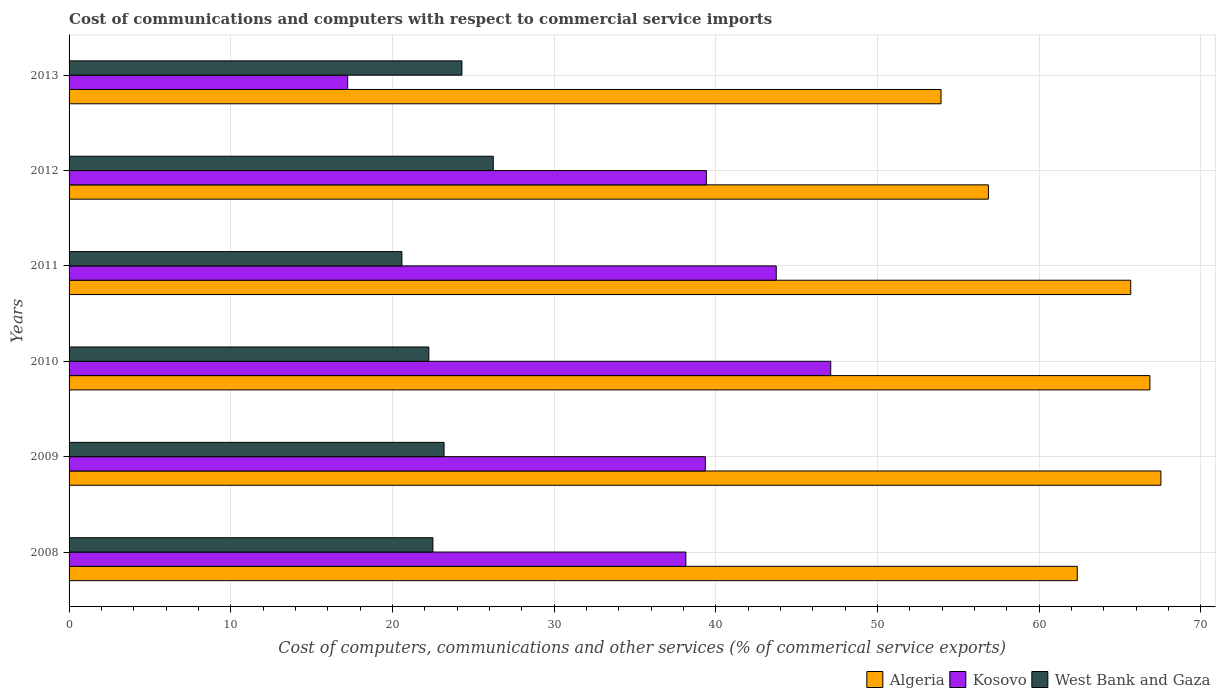How many bars are there on the 6th tick from the top?
Your response must be concise. 3. How many bars are there on the 2nd tick from the bottom?
Keep it short and to the point. 3. What is the cost of communications and computers in West Bank and Gaza in 2012?
Offer a terse response. 26.24. Across all years, what is the maximum cost of communications and computers in Kosovo?
Offer a very short reply. 47.11. Across all years, what is the minimum cost of communications and computers in Kosovo?
Your answer should be very brief. 17.23. In which year was the cost of communications and computers in West Bank and Gaza minimum?
Offer a terse response. 2011. What is the total cost of communications and computers in Algeria in the graph?
Offer a terse response. 373.2. What is the difference between the cost of communications and computers in Algeria in 2011 and that in 2013?
Provide a succinct answer. 11.73. What is the difference between the cost of communications and computers in West Bank and Gaza in 2011 and the cost of communications and computers in Kosovo in 2012?
Your answer should be very brief. -18.83. What is the average cost of communications and computers in West Bank and Gaza per year?
Your answer should be very brief. 23.18. In the year 2013, what is the difference between the cost of communications and computers in Algeria and cost of communications and computers in West Bank and Gaza?
Provide a short and direct response. 29.63. What is the ratio of the cost of communications and computers in Kosovo in 2012 to that in 2013?
Keep it short and to the point. 2.29. Is the cost of communications and computers in Algeria in 2008 less than that in 2013?
Ensure brevity in your answer.  No. Is the difference between the cost of communications and computers in Algeria in 2009 and 2013 greater than the difference between the cost of communications and computers in West Bank and Gaza in 2009 and 2013?
Keep it short and to the point. Yes. What is the difference between the highest and the second highest cost of communications and computers in West Bank and Gaza?
Provide a short and direct response. 1.94. What is the difference between the highest and the lowest cost of communications and computers in Kosovo?
Your response must be concise. 29.88. Is the sum of the cost of communications and computers in Kosovo in 2011 and 2013 greater than the maximum cost of communications and computers in West Bank and Gaza across all years?
Your answer should be compact. Yes. What does the 3rd bar from the top in 2010 represents?
Your answer should be compact. Algeria. What does the 1st bar from the bottom in 2012 represents?
Provide a succinct answer. Algeria. How many bars are there?
Offer a terse response. 18. Are all the bars in the graph horizontal?
Offer a very short reply. Yes. How many years are there in the graph?
Your answer should be very brief. 6. What is the difference between two consecutive major ticks on the X-axis?
Provide a short and direct response. 10. Are the values on the major ticks of X-axis written in scientific E-notation?
Offer a very short reply. No. Does the graph contain any zero values?
Keep it short and to the point. No. How many legend labels are there?
Offer a terse response. 3. What is the title of the graph?
Offer a terse response. Cost of communications and computers with respect to commercial service imports. What is the label or title of the X-axis?
Give a very brief answer. Cost of computers, communications and other services (% of commerical service exports). What is the Cost of computers, communications and other services (% of commerical service exports) of Algeria in 2008?
Keep it short and to the point. 62.36. What is the Cost of computers, communications and other services (% of commerical service exports) of Kosovo in 2008?
Make the answer very short. 38.15. What is the Cost of computers, communications and other services (% of commerical service exports) of West Bank and Gaza in 2008?
Provide a short and direct response. 22.5. What is the Cost of computers, communications and other services (% of commerical service exports) in Algeria in 2009?
Provide a succinct answer. 67.53. What is the Cost of computers, communications and other services (% of commerical service exports) in Kosovo in 2009?
Make the answer very short. 39.35. What is the Cost of computers, communications and other services (% of commerical service exports) of West Bank and Gaza in 2009?
Your answer should be compact. 23.19. What is the Cost of computers, communications and other services (% of commerical service exports) of Algeria in 2010?
Offer a terse response. 66.85. What is the Cost of computers, communications and other services (% of commerical service exports) of Kosovo in 2010?
Make the answer very short. 47.11. What is the Cost of computers, communications and other services (% of commerical service exports) of West Bank and Gaza in 2010?
Keep it short and to the point. 22.25. What is the Cost of computers, communications and other services (% of commerical service exports) of Algeria in 2011?
Give a very brief answer. 65.67. What is the Cost of computers, communications and other services (% of commerical service exports) of Kosovo in 2011?
Your answer should be very brief. 43.74. What is the Cost of computers, communications and other services (% of commerical service exports) in West Bank and Gaza in 2011?
Your answer should be compact. 20.58. What is the Cost of computers, communications and other services (% of commerical service exports) in Algeria in 2012?
Make the answer very short. 56.86. What is the Cost of computers, communications and other services (% of commerical service exports) in Kosovo in 2012?
Your answer should be compact. 39.42. What is the Cost of computers, communications and other services (% of commerical service exports) of West Bank and Gaza in 2012?
Offer a very short reply. 26.24. What is the Cost of computers, communications and other services (% of commerical service exports) in Algeria in 2013?
Offer a terse response. 53.93. What is the Cost of computers, communications and other services (% of commerical service exports) of Kosovo in 2013?
Your answer should be very brief. 17.23. What is the Cost of computers, communications and other services (% of commerical service exports) in West Bank and Gaza in 2013?
Offer a very short reply. 24.3. Across all years, what is the maximum Cost of computers, communications and other services (% of commerical service exports) in Algeria?
Give a very brief answer. 67.53. Across all years, what is the maximum Cost of computers, communications and other services (% of commerical service exports) of Kosovo?
Provide a short and direct response. 47.11. Across all years, what is the maximum Cost of computers, communications and other services (% of commerical service exports) in West Bank and Gaza?
Provide a succinct answer. 26.24. Across all years, what is the minimum Cost of computers, communications and other services (% of commerical service exports) of Algeria?
Provide a succinct answer. 53.93. Across all years, what is the minimum Cost of computers, communications and other services (% of commerical service exports) of Kosovo?
Provide a succinct answer. 17.23. Across all years, what is the minimum Cost of computers, communications and other services (% of commerical service exports) of West Bank and Gaza?
Make the answer very short. 20.58. What is the total Cost of computers, communications and other services (% of commerical service exports) in Algeria in the graph?
Offer a very short reply. 373.2. What is the total Cost of computers, communications and other services (% of commerical service exports) of Kosovo in the graph?
Your response must be concise. 225. What is the total Cost of computers, communications and other services (% of commerical service exports) in West Bank and Gaza in the graph?
Provide a succinct answer. 139.07. What is the difference between the Cost of computers, communications and other services (% of commerical service exports) in Algeria in 2008 and that in 2009?
Make the answer very short. -5.17. What is the difference between the Cost of computers, communications and other services (% of commerical service exports) in Kosovo in 2008 and that in 2009?
Your response must be concise. -1.2. What is the difference between the Cost of computers, communications and other services (% of commerical service exports) of West Bank and Gaza in 2008 and that in 2009?
Make the answer very short. -0.69. What is the difference between the Cost of computers, communications and other services (% of commerical service exports) of Algeria in 2008 and that in 2010?
Provide a short and direct response. -4.49. What is the difference between the Cost of computers, communications and other services (% of commerical service exports) in Kosovo in 2008 and that in 2010?
Keep it short and to the point. -8.96. What is the difference between the Cost of computers, communications and other services (% of commerical service exports) of West Bank and Gaza in 2008 and that in 2010?
Your answer should be very brief. 0.25. What is the difference between the Cost of computers, communications and other services (% of commerical service exports) of Algeria in 2008 and that in 2011?
Provide a short and direct response. -3.31. What is the difference between the Cost of computers, communications and other services (% of commerical service exports) in Kosovo in 2008 and that in 2011?
Offer a very short reply. -5.59. What is the difference between the Cost of computers, communications and other services (% of commerical service exports) in West Bank and Gaza in 2008 and that in 2011?
Give a very brief answer. 1.92. What is the difference between the Cost of computers, communications and other services (% of commerical service exports) of Algeria in 2008 and that in 2012?
Make the answer very short. 5.5. What is the difference between the Cost of computers, communications and other services (% of commerical service exports) of Kosovo in 2008 and that in 2012?
Ensure brevity in your answer.  -1.27. What is the difference between the Cost of computers, communications and other services (% of commerical service exports) in West Bank and Gaza in 2008 and that in 2012?
Give a very brief answer. -3.73. What is the difference between the Cost of computers, communications and other services (% of commerical service exports) in Algeria in 2008 and that in 2013?
Keep it short and to the point. 8.43. What is the difference between the Cost of computers, communications and other services (% of commerical service exports) of Kosovo in 2008 and that in 2013?
Ensure brevity in your answer.  20.92. What is the difference between the Cost of computers, communications and other services (% of commerical service exports) in West Bank and Gaza in 2008 and that in 2013?
Provide a succinct answer. -1.79. What is the difference between the Cost of computers, communications and other services (% of commerical service exports) in Algeria in 2009 and that in 2010?
Provide a short and direct response. 0.68. What is the difference between the Cost of computers, communications and other services (% of commerical service exports) in Kosovo in 2009 and that in 2010?
Offer a terse response. -7.76. What is the difference between the Cost of computers, communications and other services (% of commerical service exports) of West Bank and Gaza in 2009 and that in 2010?
Your answer should be very brief. 0.94. What is the difference between the Cost of computers, communications and other services (% of commerical service exports) in Algeria in 2009 and that in 2011?
Provide a succinct answer. 1.87. What is the difference between the Cost of computers, communications and other services (% of commerical service exports) of Kosovo in 2009 and that in 2011?
Give a very brief answer. -4.39. What is the difference between the Cost of computers, communications and other services (% of commerical service exports) in West Bank and Gaza in 2009 and that in 2011?
Your answer should be compact. 2.61. What is the difference between the Cost of computers, communications and other services (% of commerical service exports) of Algeria in 2009 and that in 2012?
Your response must be concise. 10.67. What is the difference between the Cost of computers, communications and other services (% of commerical service exports) of Kosovo in 2009 and that in 2012?
Offer a very short reply. -0.07. What is the difference between the Cost of computers, communications and other services (% of commerical service exports) of West Bank and Gaza in 2009 and that in 2012?
Offer a terse response. -3.04. What is the difference between the Cost of computers, communications and other services (% of commerical service exports) in Algeria in 2009 and that in 2013?
Offer a very short reply. 13.6. What is the difference between the Cost of computers, communications and other services (% of commerical service exports) of Kosovo in 2009 and that in 2013?
Offer a very short reply. 22.12. What is the difference between the Cost of computers, communications and other services (% of commerical service exports) in West Bank and Gaza in 2009 and that in 2013?
Your response must be concise. -1.1. What is the difference between the Cost of computers, communications and other services (% of commerical service exports) in Algeria in 2010 and that in 2011?
Your answer should be compact. 1.18. What is the difference between the Cost of computers, communications and other services (% of commerical service exports) in Kosovo in 2010 and that in 2011?
Ensure brevity in your answer.  3.37. What is the difference between the Cost of computers, communications and other services (% of commerical service exports) of West Bank and Gaza in 2010 and that in 2011?
Make the answer very short. 1.67. What is the difference between the Cost of computers, communications and other services (% of commerical service exports) of Algeria in 2010 and that in 2012?
Offer a very short reply. 9.99. What is the difference between the Cost of computers, communications and other services (% of commerical service exports) of Kosovo in 2010 and that in 2012?
Make the answer very short. 7.69. What is the difference between the Cost of computers, communications and other services (% of commerical service exports) of West Bank and Gaza in 2010 and that in 2012?
Ensure brevity in your answer.  -3.98. What is the difference between the Cost of computers, communications and other services (% of commerical service exports) of Algeria in 2010 and that in 2013?
Offer a terse response. 12.92. What is the difference between the Cost of computers, communications and other services (% of commerical service exports) of Kosovo in 2010 and that in 2013?
Ensure brevity in your answer.  29.88. What is the difference between the Cost of computers, communications and other services (% of commerical service exports) of West Bank and Gaza in 2010 and that in 2013?
Your answer should be compact. -2.05. What is the difference between the Cost of computers, communications and other services (% of commerical service exports) of Algeria in 2011 and that in 2012?
Offer a terse response. 8.8. What is the difference between the Cost of computers, communications and other services (% of commerical service exports) in Kosovo in 2011 and that in 2012?
Your answer should be very brief. 4.32. What is the difference between the Cost of computers, communications and other services (% of commerical service exports) in West Bank and Gaza in 2011 and that in 2012?
Keep it short and to the point. -5.65. What is the difference between the Cost of computers, communications and other services (% of commerical service exports) of Algeria in 2011 and that in 2013?
Keep it short and to the point. 11.73. What is the difference between the Cost of computers, communications and other services (% of commerical service exports) of Kosovo in 2011 and that in 2013?
Your response must be concise. 26.51. What is the difference between the Cost of computers, communications and other services (% of commerical service exports) of West Bank and Gaza in 2011 and that in 2013?
Give a very brief answer. -3.71. What is the difference between the Cost of computers, communications and other services (% of commerical service exports) of Algeria in 2012 and that in 2013?
Make the answer very short. 2.93. What is the difference between the Cost of computers, communications and other services (% of commerical service exports) in Kosovo in 2012 and that in 2013?
Ensure brevity in your answer.  22.19. What is the difference between the Cost of computers, communications and other services (% of commerical service exports) in West Bank and Gaza in 2012 and that in 2013?
Give a very brief answer. 1.94. What is the difference between the Cost of computers, communications and other services (% of commerical service exports) in Algeria in 2008 and the Cost of computers, communications and other services (% of commerical service exports) in Kosovo in 2009?
Your response must be concise. 23.01. What is the difference between the Cost of computers, communications and other services (% of commerical service exports) in Algeria in 2008 and the Cost of computers, communications and other services (% of commerical service exports) in West Bank and Gaza in 2009?
Offer a terse response. 39.17. What is the difference between the Cost of computers, communications and other services (% of commerical service exports) of Kosovo in 2008 and the Cost of computers, communications and other services (% of commerical service exports) of West Bank and Gaza in 2009?
Your answer should be compact. 14.96. What is the difference between the Cost of computers, communications and other services (% of commerical service exports) of Algeria in 2008 and the Cost of computers, communications and other services (% of commerical service exports) of Kosovo in 2010?
Your answer should be compact. 15.25. What is the difference between the Cost of computers, communications and other services (% of commerical service exports) in Algeria in 2008 and the Cost of computers, communications and other services (% of commerical service exports) in West Bank and Gaza in 2010?
Your response must be concise. 40.11. What is the difference between the Cost of computers, communications and other services (% of commerical service exports) in Kosovo in 2008 and the Cost of computers, communications and other services (% of commerical service exports) in West Bank and Gaza in 2010?
Your answer should be compact. 15.9. What is the difference between the Cost of computers, communications and other services (% of commerical service exports) of Algeria in 2008 and the Cost of computers, communications and other services (% of commerical service exports) of Kosovo in 2011?
Your answer should be compact. 18.62. What is the difference between the Cost of computers, communications and other services (% of commerical service exports) in Algeria in 2008 and the Cost of computers, communications and other services (% of commerical service exports) in West Bank and Gaza in 2011?
Your answer should be compact. 41.77. What is the difference between the Cost of computers, communications and other services (% of commerical service exports) of Kosovo in 2008 and the Cost of computers, communications and other services (% of commerical service exports) of West Bank and Gaza in 2011?
Provide a short and direct response. 17.57. What is the difference between the Cost of computers, communications and other services (% of commerical service exports) in Algeria in 2008 and the Cost of computers, communications and other services (% of commerical service exports) in Kosovo in 2012?
Provide a short and direct response. 22.94. What is the difference between the Cost of computers, communications and other services (% of commerical service exports) of Algeria in 2008 and the Cost of computers, communications and other services (% of commerical service exports) of West Bank and Gaza in 2012?
Make the answer very short. 36.12. What is the difference between the Cost of computers, communications and other services (% of commerical service exports) in Kosovo in 2008 and the Cost of computers, communications and other services (% of commerical service exports) in West Bank and Gaza in 2012?
Give a very brief answer. 11.91. What is the difference between the Cost of computers, communications and other services (% of commerical service exports) of Algeria in 2008 and the Cost of computers, communications and other services (% of commerical service exports) of Kosovo in 2013?
Keep it short and to the point. 45.13. What is the difference between the Cost of computers, communications and other services (% of commerical service exports) in Algeria in 2008 and the Cost of computers, communications and other services (% of commerical service exports) in West Bank and Gaza in 2013?
Your answer should be compact. 38.06. What is the difference between the Cost of computers, communications and other services (% of commerical service exports) of Kosovo in 2008 and the Cost of computers, communications and other services (% of commerical service exports) of West Bank and Gaza in 2013?
Offer a terse response. 13.85. What is the difference between the Cost of computers, communications and other services (% of commerical service exports) of Algeria in 2009 and the Cost of computers, communications and other services (% of commerical service exports) of Kosovo in 2010?
Offer a terse response. 20.42. What is the difference between the Cost of computers, communications and other services (% of commerical service exports) of Algeria in 2009 and the Cost of computers, communications and other services (% of commerical service exports) of West Bank and Gaza in 2010?
Give a very brief answer. 45.28. What is the difference between the Cost of computers, communications and other services (% of commerical service exports) of Kosovo in 2009 and the Cost of computers, communications and other services (% of commerical service exports) of West Bank and Gaza in 2010?
Provide a succinct answer. 17.1. What is the difference between the Cost of computers, communications and other services (% of commerical service exports) in Algeria in 2009 and the Cost of computers, communications and other services (% of commerical service exports) in Kosovo in 2011?
Offer a terse response. 23.79. What is the difference between the Cost of computers, communications and other services (% of commerical service exports) in Algeria in 2009 and the Cost of computers, communications and other services (% of commerical service exports) in West Bank and Gaza in 2011?
Ensure brevity in your answer.  46.95. What is the difference between the Cost of computers, communications and other services (% of commerical service exports) in Kosovo in 2009 and the Cost of computers, communications and other services (% of commerical service exports) in West Bank and Gaza in 2011?
Your response must be concise. 18.77. What is the difference between the Cost of computers, communications and other services (% of commerical service exports) in Algeria in 2009 and the Cost of computers, communications and other services (% of commerical service exports) in Kosovo in 2012?
Keep it short and to the point. 28.11. What is the difference between the Cost of computers, communications and other services (% of commerical service exports) in Algeria in 2009 and the Cost of computers, communications and other services (% of commerical service exports) in West Bank and Gaza in 2012?
Keep it short and to the point. 41.29. What is the difference between the Cost of computers, communications and other services (% of commerical service exports) in Kosovo in 2009 and the Cost of computers, communications and other services (% of commerical service exports) in West Bank and Gaza in 2012?
Offer a terse response. 13.12. What is the difference between the Cost of computers, communications and other services (% of commerical service exports) in Algeria in 2009 and the Cost of computers, communications and other services (% of commerical service exports) in Kosovo in 2013?
Provide a succinct answer. 50.3. What is the difference between the Cost of computers, communications and other services (% of commerical service exports) in Algeria in 2009 and the Cost of computers, communications and other services (% of commerical service exports) in West Bank and Gaza in 2013?
Offer a terse response. 43.23. What is the difference between the Cost of computers, communications and other services (% of commerical service exports) in Kosovo in 2009 and the Cost of computers, communications and other services (% of commerical service exports) in West Bank and Gaza in 2013?
Give a very brief answer. 15.05. What is the difference between the Cost of computers, communications and other services (% of commerical service exports) in Algeria in 2010 and the Cost of computers, communications and other services (% of commerical service exports) in Kosovo in 2011?
Keep it short and to the point. 23.11. What is the difference between the Cost of computers, communications and other services (% of commerical service exports) in Algeria in 2010 and the Cost of computers, communications and other services (% of commerical service exports) in West Bank and Gaza in 2011?
Offer a terse response. 46.27. What is the difference between the Cost of computers, communications and other services (% of commerical service exports) of Kosovo in 2010 and the Cost of computers, communications and other services (% of commerical service exports) of West Bank and Gaza in 2011?
Provide a succinct answer. 26.52. What is the difference between the Cost of computers, communications and other services (% of commerical service exports) of Algeria in 2010 and the Cost of computers, communications and other services (% of commerical service exports) of Kosovo in 2012?
Your answer should be compact. 27.43. What is the difference between the Cost of computers, communications and other services (% of commerical service exports) of Algeria in 2010 and the Cost of computers, communications and other services (% of commerical service exports) of West Bank and Gaza in 2012?
Your response must be concise. 40.61. What is the difference between the Cost of computers, communications and other services (% of commerical service exports) in Kosovo in 2010 and the Cost of computers, communications and other services (% of commerical service exports) in West Bank and Gaza in 2012?
Your answer should be compact. 20.87. What is the difference between the Cost of computers, communications and other services (% of commerical service exports) in Algeria in 2010 and the Cost of computers, communications and other services (% of commerical service exports) in Kosovo in 2013?
Offer a very short reply. 49.62. What is the difference between the Cost of computers, communications and other services (% of commerical service exports) of Algeria in 2010 and the Cost of computers, communications and other services (% of commerical service exports) of West Bank and Gaza in 2013?
Offer a very short reply. 42.55. What is the difference between the Cost of computers, communications and other services (% of commerical service exports) in Kosovo in 2010 and the Cost of computers, communications and other services (% of commerical service exports) in West Bank and Gaza in 2013?
Give a very brief answer. 22.81. What is the difference between the Cost of computers, communications and other services (% of commerical service exports) of Algeria in 2011 and the Cost of computers, communications and other services (% of commerical service exports) of Kosovo in 2012?
Offer a terse response. 26.25. What is the difference between the Cost of computers, communications and other services (% of commerical service exports) of Algeria in 2011 and the Cost of computers, communications and other services (% of commerical service exports) of West Bank and Gaza in 2012?
Keep it short and to the point. 39.43. What is the difference between the Cost of computers, communications and other services (% of commerical service exports) of Kosovo in 2011 and the Cost of computers, communications and other services (% of commerical service exports) of West Bank and Gaza in 2012?
Provide a succinct answer. 17.5. What is the difference between the Cost of computers, communications and other services (% of commerical service exports) in Algeria in 2011 and the Cost of computers, communications and other services (% of commerical service exports) in Kosovo in 2013?
Offer a terse response. 48.43. What is the difference between the Cost of computers, communications and other services (% of commerical service exports) in Algeria in 2011 and the Cost of computers, communications and other services (% of commerical service exports) in West Bank and Gaza in 2013?
Provide a succinct answer. 41.37. What is the difference between the Cost of computers, communications and other services (% of commerical service exports) of Kosovo in 2011 and the Cost of computers, communications and other services (% of commerical service exports) of West Bank and Gaza in 2013?
Your answer should be very brief. 19.44. What is the difference between the Cost of computers, communications and other services (% of commerical service exports) of Algeria in 2012 and the Cost of computers, communications and other services (% of commerical service exports) of Kosovo in 2013?
Make the answer very short. 39.63. What is the difference between the Cost of computers, communications and other services (% of commerical service exports) of Algeria in 2012 and the Cost of computers, communications and other services (% of commerical service exports) of West Bank and Gaza in 2013?
Keep it short and to the point. 32.56. What is the difference between the Cost of computers, communications and other services (% of commerical service exports) in Kosovo in 2012 and the Cost of computers, communications and other services (% of commerical service exports) in West Bank and Gaza in 2013?
Your answer should be compact. 15.12. What is the average Cost of computers, communications and other services (% of commerical service exports) of Algeria per year?
Your response must be concise. 62.2. What is the average Cost of computers, communications and other services (% of commerical service exports) of Kosovo per year?
Offer a very short reply. 37.5. What is the average Cost of computers, communications and other services (% of commerical service exports) of West Bank and Gaza per year?
Keep it short and to the point. 23.18. In the year 2008, what is the difference between the Cost of computers, communications and other services (% of commerical service exports) of Algeria and Cost of computers, communications and other services (% of commerical service exports) of Kosovo?
Provide a short and direct response. 24.21. In the year 2008, what is the difference between the Cost of computers, communications and other services (% of commerical service exports) in Algeria and Cost of computers, communications and other services (% of commerical service exports) in West Bank and Gaza?
Your response must be concise. 39.86. In the year 2008, what is the difference between the Cost of computers, communications and other services (% of commerical service exports) in Kosovo and Cost of computers, communications and other services (% of commerical service exports) in West Bank and Gaza?
Make the answer very short. 15.65. In the year 2009, what is the difference between the Cost of computers, communications and other services (% of commerical service exports) of Algeria and Cost of computers, communications and other services (% of commerical service exports) of Kosovo?
Your answer should be compact. 28.18. In the year 2009, what is the difference between the Cost of computers, communications and other services (% of commerical service exports) in Algeria and Cost of computers, communications and other services (% of commerical service exports) in West Bank and Gaza?
Ensure brevity in your answer.  44.34. In the year 2009, what is the difference between the Cost of computers, communications and other services (% of commerical service exports) in Kosovo and Cost of computers, communications and other services (% of commerical service exports) in West Bank and Gaza?
Offer a terse response. 16.16. In the year 2010, what is the difference between the Cost of computers, communications and other services (% of commerical service exports) in Algeria and Cost of computers, communications and other services (% of commerical service exports) in Kosovo?
Keep it short and to the point. 19.74. In the year 2010, what is the difference between the Cost of computers, communications and other services (% of commerical service exports) of Algeria and Cost of computers, communications and other services (% of commerical service exports) of West Bank and Gaza?
Ensure brevity in your answer.  44.6. In the year 2010, what is the difference between the Cost of computers, communications and other services (% of commerical service exports) in Kosovo and Cost of computers, communications and other services (% of commerical service exports) in West Bank and Gaza?
Give a very brief answer. 24.86. In the year 2011, what is the difference between the Cost of computers, communications and other services (% of commerical service exports) in Algeria and Cost of computers, communications and other services (% of commerical service exports) in Kosovo?
Give a very brief answer. 21.93. In the year 2011, what is the difference between the Cost of computers, communications and other services (% of commerical service exports) in Algeria and Cost of computers, communications and other services (% of commerical service exports) in West Bank and Gaza?
Your answer should be very brief. 45.08. In the year 2011, what is the difference between the Cost of computers, communications and other services (% of commerical service exports) of Kosovo and Cost of computers, communications and other services (% of commerical service exports) of West Bank and Gaza?
Make the answer very short. 23.16. In the year 2012, what is the difference between the Cost of computers, communications and other services (% of commerical service exports) of Algeria and Cost of computers, communications and other services (% of commerical service exports) of Kosovo?
Offer a terse response. 17.44. In the year 2012, what is the difference between the Cost of computers, communications and other services (% of commerical service exports) of Algeria and Cost of computers, communications and other services (% of commerical service exports) of West Bank and Gaza?
Give a very brief answer. 30.62. In the year 2012, what is the difference between the Cost of computers, communications and other services (% of commerical service exports) in Kosovo and Cost of computers, communications and other services (% of commerical service exports) in West Bank and Gaza?
Your answer should be compact. 13.18. In the year 2013, what is the difference between the Cost of computers, communications and other services (% of commerical service exports) in Algeria and Cost of computers, communications and other services (% of commerical service exports) in Kosovo?
Keep it short and to the point. 36.7. In the year 2013, what is the difference between the Cost of computers, communications and other services (% of commerical service exports) in Algeria and Cost of computers, communications and other services (% of commerical service exports) in West Bank and Gaza?
Keep it short and to the point. 29.63. In the year 2013, what is the difference between the Cost of computers, communications and other services (% of commerical service exports) of Kosovo and Cost of computers, communications and other services (% of commerical service exports) of West Bank and Gaza?
Your answer should be very brief. -7.07. What is the ratio of the Cost of computers, communications and other services (% of commerical service exports) of Algeria in 2008 to that in 2009?
Your answer should be compact. 0.92. What is the ratio of the Cost of computers, communications and other services (% of commerical service exports) in Kosovo in 2008 to that in 2009?
Your answer should be compact. 0.97. What is the ratio of the Cost of computers, communications and other services (% of commerical service exports) of West Bank and Gaza in 2008 to that in 2009?
Offer a terse response. 0.97. What is the ratio of the Cost of computers, communications and other services (% of commerical service exports) in Algeria in 2008 to that in 2010?
Your response must be concise. 0.93. What is the ratio of the Cost of computers, communications and other services (% of commerical service exports) of Kosovo in 2008 to that in 2010?
Your response must be concise. 0.81. What is the ratio of the Cost of computers, communications and other services (% of commerical service exports) of West Bank and Gaza in 2008 to that in 2010?
Ensure brevity in your answer.  1.01. What is the ratio of the Cost of computers, communications and other services (% of commerical service exports) of Algeria in 2008 to that in 2011?
Your answer should be very brief. 0.95. What is the ratio of the Cost of computers, communications and other services (% of commerical service exports) of Kosovo in 2008 to that in 2011?
Keep it short and to the point. 0.87. What is the ratio of the Cost of computers, communications and other services (% of commerical service exports) of West Bank and Gaza in 2008 to that in 2011?
Offer a terse response. 1.09. What is the ratio of the Cost of computers, communications and other services (% of commerical service exports) in Algeria in 2008 to that in 2012?
Your answer should be very brief. 1.1. What is the ratio of the Cost of computers, communications and other services (% of commerical service exports) of Kosovo in 2008 to that in 2012?
Your response must be concise. 0.97. What is the ratio of the Cost of computers, communications and other services (% of commerical service exports) in West Bank and Gaza in 2008 to that in 2012?
Provide a short and direct response. 0.86. What is the ratio of the Cost of computers, communications and other services (% of commerical service exports) in Algeria in 2008 to that in 2013?
Provide a short and direct response. 1.16. What is the ratio of the Cost of computers, communications and other services (% of commerical service exports) in Kosovo in 2008 to that in 2013?
Offer a very short reply. 2.21. What is the ratio of the Cost of computers, communications and other services (% of commerical service exports) in West Bank and Gaza in 2008 to that in 2013?
Make the answer very short. 0.93. What is the ratio of the Cost of computers, communications and other services (% of commerical service exports) in Algeria in 2009 to that in 2010?
Provide a short and direct response. 1.01. What is the ratio of the Cost of computers, communications and other services (% of commerical service exports) of Kosovo in 2009 to that in 2010?
Your answer should be compact. 0.84. What is the ratio of the Cost of computers, communications and other services (% of commerical service exports) in West Bank and Gaza in 2009 to that in 2010?
Offer a very short reply. 1.04. What is the ratio of the Cost of computers, communications and other services (% of commerical service exports) in Algeria in 2009 to that in 2011?
Ensure brevity in your answer.  1.03. What is the ratio of the Cost of computers, communications and other services (% of commerical service exports) of Kosovo in 2009 to that in 2011?
Offer a very short reply. 0.9. What is the ratio of the Cost of computers, communications and other services (% of commerical service exports) of West Bank and Gaza in 2009 to that in 2011?
Give a very brief answer. 1.13. What is the ratio of the Cost of computers, communications and other services (% of commerical service exports) in Algeria in 2009 to that in 2012?
Make the answer very short. 1.19. What is the ratio of the Cost of computers, communications and other services (% of commerical service exports) in West Bank and Gaza in 2009 to that in 2012?
Your answer should be compact. 0.88. What is the ratio of the Cost of computers, communications and other services (% of commerical service exports) in Algeria in 2009 to that in 2013?
Give a very brief answer. 1.25. What is the ratio of the Cost of computers, communications and other services (% of commerical service exports) in Kosovo in 2009 to that in 2013?
Your answer should be very brief. 2.28. What is the ratio of the Cost of computers, communications and other services (% of commerical service exports) of West Bank and Gaza in 2009 to that in 2013?
Your answer should be compact. 0.95. What is the ratio of the Cost of computers, communications and other services (% of commerical service exports) in Kosovo in 2010 to that in 2011?
Offer a very short reply. 1.08. What is the ratio of the Cost of computers, communications and other services (% of commerical service exports) in West Bank and Gaza in 2010 to that in 2011?
Your response must be concise. 1.08. What is the ratio of the Cost of computers, communications and other services (% of commerical service exports) in Algeria in 2010 to that in 2012?
Your answer should be very brief. 1.18. What is the ratio of the Cost of computers, communications and other services (% of commerical service exports) of Kosovo in 2010 to that in 2012?
Keep it short and to the point. 1.2. What is the ratio of the Cost of computers, communications and other services (% of commerical service exports) in West Bank and Gaza in 2010 to that in 2012?
Your response must be concise. 0.85. What is the ratio of the Cost of computers, communications and other services (% of commerical service exports) in Algeria in 2010 to that in 2013?
Ensure brevity in your answer.  1.24. What is the ratio of the Cost of computers, communications and other services (% of commerical service exports) of Kosovo in 2010 to that in 2013?
Offer a very short reply. 2.73. What is the ratio of the Cost of computers, communications and other services (% of commerical service exports) of West Bank and Gaza in 2010 to that in 2013?
Provide a short and direct response. 0.92. What is the ratio of the Cost of computers, communications and other services (% of commerical service exports) of Algeria in 2011 to that in 2012?
Provide a succinct answer. 1.15. What is the ratio of the Cost of computers, communications and other services (% of commerical service exports) in Kosovo in 2011 to that in 2012?
Your answer should be compact. 1.11. What is the ratio of the Cost of computers, communications and other services (% of commerical service exports) of West Bank and Gaza in 2011 to that in 2012?
Provide a short and direct response. 0.78. What is the ratio of the Cost of computers, communications and other services (% of commerical service exports) of Algeria in 2011 to that in 2013?
Give a very brief answer. 1.22. What is the ratio of the Cost of computers, communications and other services (% of commerical service exports) in Kosovo in 2011 to that in 2013?
Provide a succinct answer. 2.54. What is the ratio of the Cost of computers, communications and other services (% of commerical service exports) of West Bank and Gaza in 2011 to that in 2013?
Offer a terse response. 0.85. What is the ratio of the Cost of computers, communications and other services (% of commerical service exports) of Algeria in 2012 to that in 2013?
Keep it short and to the point. 1.05. What is the ratio of the Cost of computers, communications and other services (% of commerical service exports) of Kosovo in 2012 to that in 2013?
Give a very brief answer. 2.29. What is the ratio of the Cost of computers, communications and other services (% of commerical service exports) of West Bank and Gaza in 2012 to that in 2013?
Give a very brief answer. 1.08. What is the difference between the highest and the second highest Cost of computers, communications and other services (% of commerical service exports) in Algeria?
Offer a very short reply. 0.68. What is the difference between the highest and the second highest Cost of computers, communications and other services (% of commerical service exports) of Kosovo?
Ensure brevity in your answer.  3.37. What is the difference between the highest and the second highest Cost of computers, communications and other services (% of commerical service exports) in West Bank and Gaza?
Make the answer very short. 1.94. What is the difference between the highest and the lowest Cost of computers, communications and other services (% of commerical service exports) in Algeria?
Offer a very short reply. 13.6. What is the difference between the highest and the lowest Cost of computers, communications and other services (% of commerical service exports) of Kosovo?
Provide a succinct answer. 29.88. What is the difference between the highest and the lowest Cost of computers, communications and other services (% of commerical service exports) in West Bank and Gaza?
Offer a terse response. 5.65. 